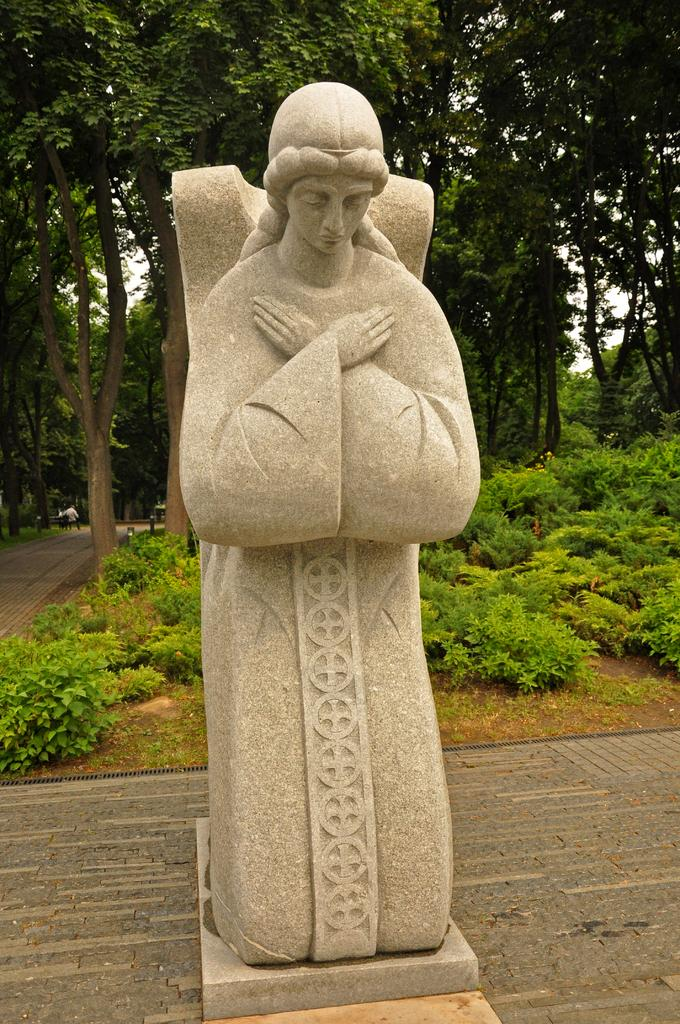What is the main subject of the image? There is a statue of a woman in the image. What can be seen behind the statue? There are many plants and trees behind the statue. What is the color of the sky in the background of the image? The sky is white in the background of the image. How many bikes are parked next to the statue in the image? There are no bikes present in the image; it only features a statue of a woman, plants, trees, and a white sky. 